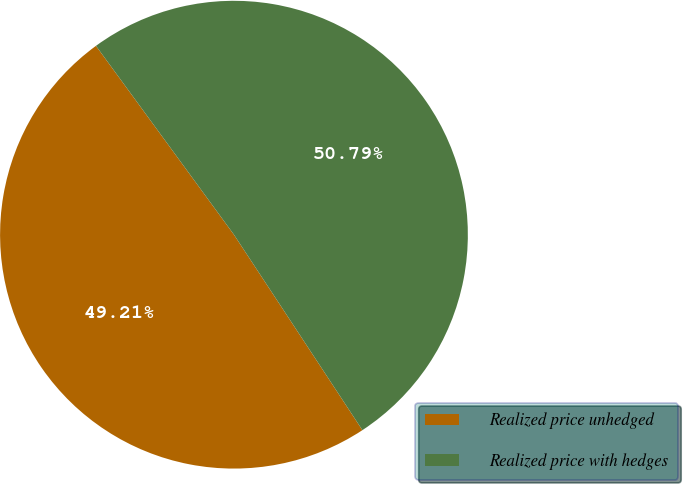<chart> <loc_0><loc_0><loc_500><loc_500><pie_chart><fcel>Realized price unhedged<fcel>Realized price with hedges<nl><fcel>49.21%<fcel>50.79%<nl></chart> 